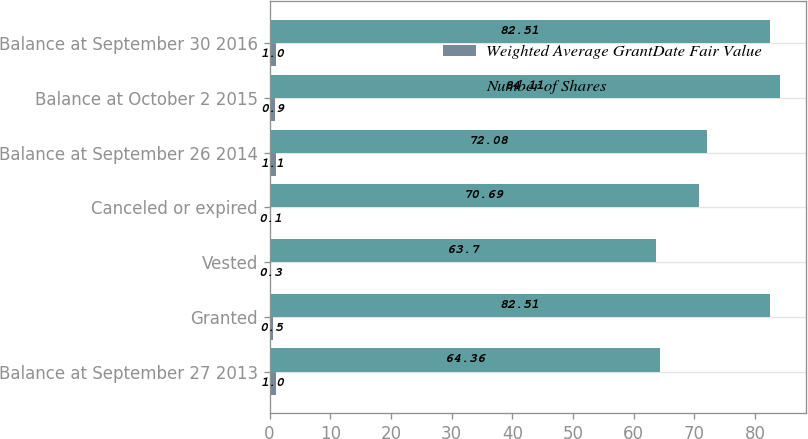<chart> <loc_0><loc_0><loc_500><loc_500><stacked_bar_chart><ecel><fcel>Balance at September 27 2013<fcel>Granted<fcel>Vested<fcel>Canceled or expired<fcel>Balance at September 26 2014<fcel>Balance at October 2 2015<fcel>Balance at September 30 2016<nl><fcel>Weighted Average GrantDate Fair Value<fcel>1<fcel>0.5<fcel>0.3<fcel>0.1<fcel>1.1<fcel>0.9<fcel>1<nl><fcel>Number of Shares<fcel>64.36<fcel>82.51<fcel>63.7<fcel>70.69<fcel>72.08<fcel>84.11<fcel>82.51<nl></chart> 